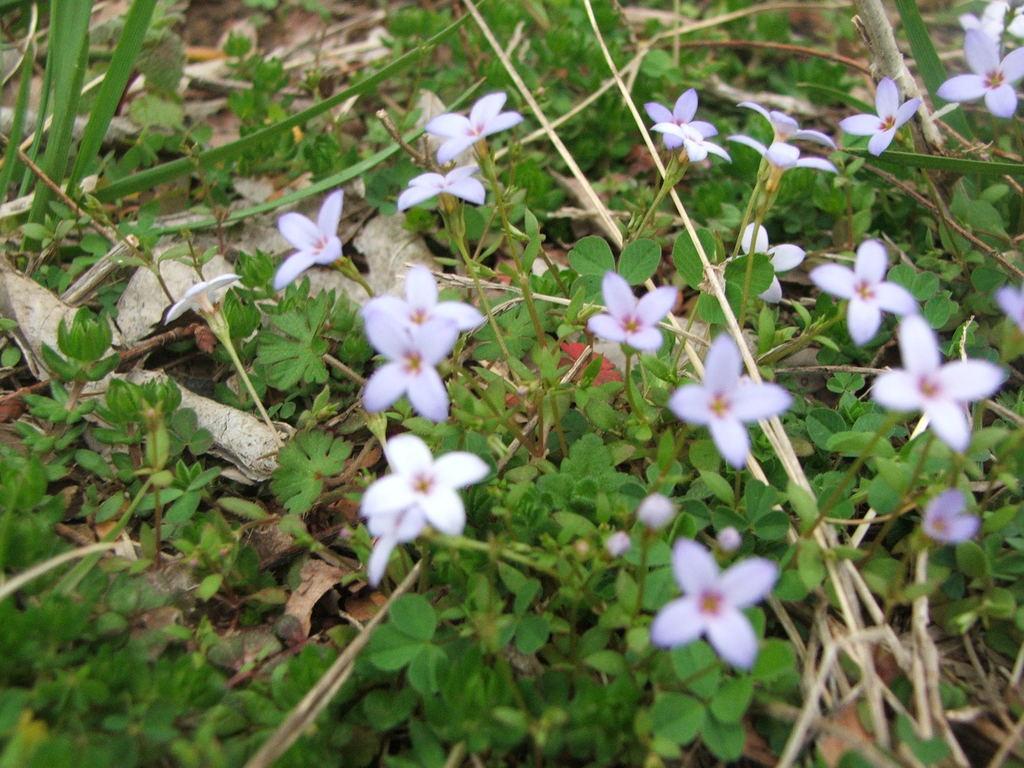Please provide a concise description of this image. In this picture we can see a few flowers and green plants. There are a few dry leaves on the grass. 